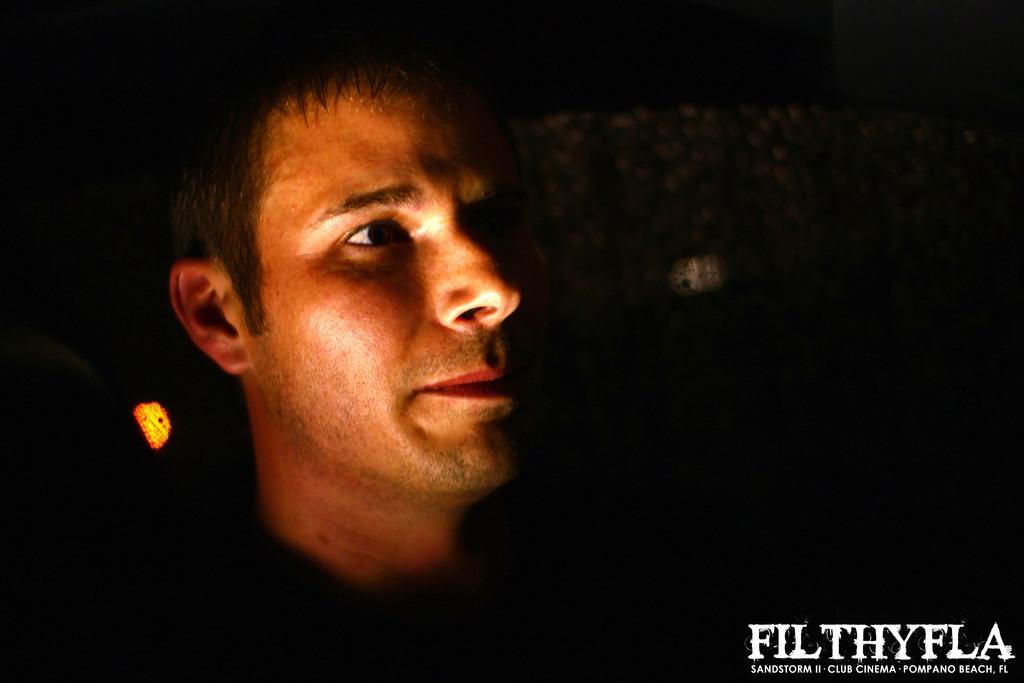Please provide a concise description of this image. In the image there is a man visible and the background is total dark. 